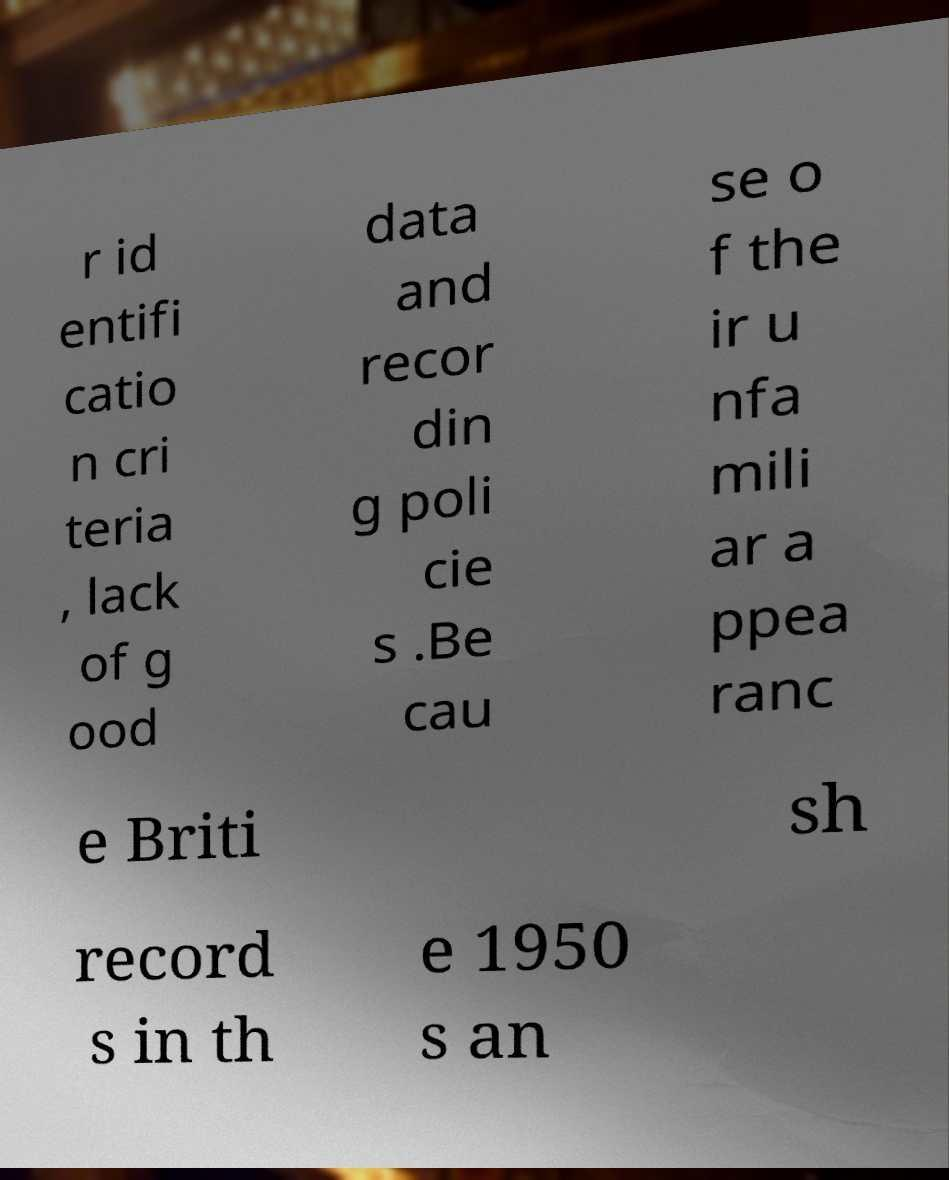What messages or text are displayed in this image? I need them in a readable, typed format. r id entifi catio n cri teria , lack of g ood data and recor din g poli cie s .Be cau se o f the ir u nfa mili ar a ppea ranc e Briti sh record s in th e 1950 s an 